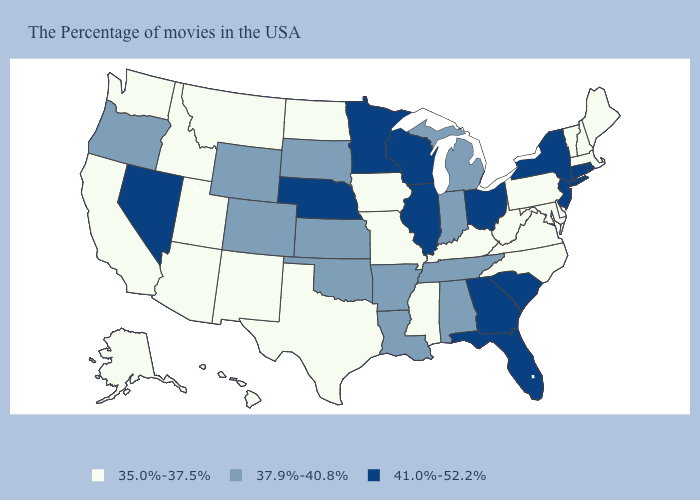Does South Dakota have the lowest value in the MidWest?
Short answer required. No. What is the value of Massachusetts?
Quick response, please. 35.0%-37.5%. What is the value of Minnesota?
Answer briefly. 41.0%-52.2%. Among the states that border South Dakota , does Wyoming have the lowest value?
Answer briefly. No. Among the states that border Tennessee , does Georgia have the highest value?
Keep it brief. Yes. What is the value of Michigan?
Be succinct. 37.9%-40.8%. Does Connecticut have the same value as Oklahoma?
Concise answer only. No. Which states have the lowest value in the South?
Give a very brief answer. Delaware, Maryland, Virginia, North Carolina, West Virginia, Kentucky, Mississippi, Texas. What is the highest value in the MidWest ?
Keep it brief. 41.0%-52.2%. What is the value of New Mexico?
Write a very short answer. 35.0%-37.5%. Name the states that have a value in the range 35.0%-37.5%?
Write a very short answer. Maine, Massachusetts, New Hampshire, Vermont, Delaware, Maryland, Pennsylvania, Virginia, North Carolina, West Virginia, Kentucky, Mississippi, Missouri, Iowa, Texas, North Dakota, New Mexico, Utah, Montana, Arizona, Idaho, California, Washington, Alaska, Hawaii. Among the states that border Nevada , which have the lowest value?
Write a very short answer. Utah, Arizona, Idaho, California. Does New Hampshire have the highest value in the Northeast?
Short answer required. No. Does the map have missing data?
Be succinct. No. 